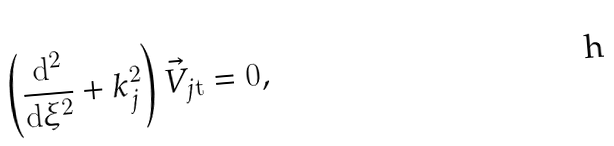Convert formula to latex. <formula><loc_0><loc_0><loc_500><loc_500>\left ( \frac { \mathrm d ^ { 2 } } { \mathrm d \xi ^ { 2 } } + k _ { j } ^ { 2 } \right ) \vec { V } _ { j \mathrm t } = 0 ,</formula> 